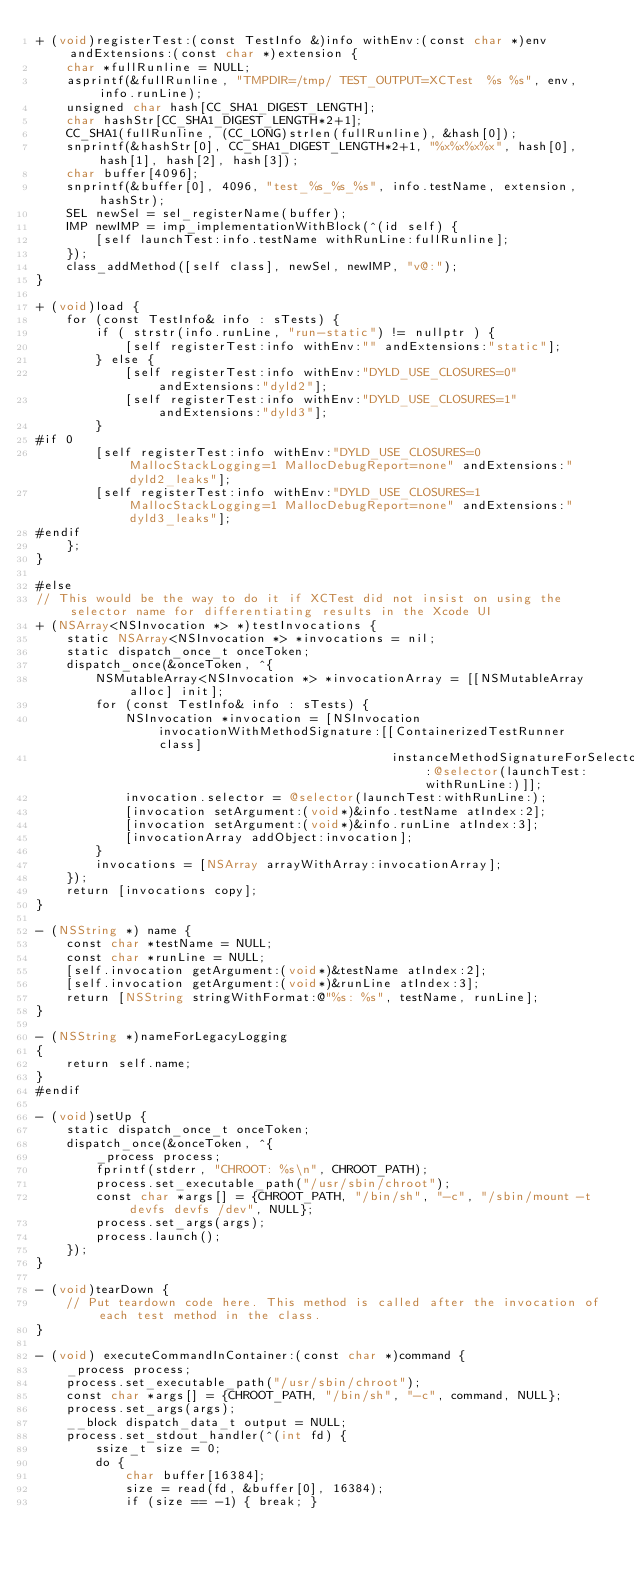<code> <loc_0><loc_0><loc_500><loc_500><_ObjectiveC_>+ (void)registerTest:(const TestInfo &)info withEnv:(const char *)env andExtensions:(const char *)extension {
    char *fullRunline = NULL;
    asprintf(&fullRunline, "TMPDIR=/tmp/ TEST_OUTPUT=XCTest  %s %s", env, info.runLine);
    unsigned char hash[CC_SHA1_DIGEST_LENGTH];
    char hashStr[CC_SHA1_DIGEST_LENGTH*2+1];
    CC_SHA1(fullRunline, (CC_LONG)strlen(fullRunline), &hash[0]);
    snprintf(&hashStr[0], CC_SHA1_DIGEST_LENGTH*2+1, "%x%x%x%x", hash[0], hash[1], hash[2], hash[3]);
    char buffer[4096];
    snprintf(&buffer[0], 4096, "test_%s_%s_%s", info.testName, extension, hashStr);
    SEL newSel = sel_registerName(buffer);
    IMP newIMP = imp_implementationWithBlock(^(id self) {
        [self launchTest:info.testName withRunLine:fullRunline];
    });
    class_addMethod([self class], newSel, newIMP, "v@:");
}

+ (void)load {
    for (const TestInfo& info : sTests) {
        if ( strstr(info.runLine, "run-static") != nullptr ) {
            [self registerTest:info withEnv:"" andExtensions:"static"];
        } else {
            [self registerTest:info withEnv:"DYLD_USE_CLOSURES=0" andExtensions:"dyld2"];
            [self registerTest:info withEnv:"DYLD_USE_CLOSURES=1" andExtensions:"dyld3"];
        }
#if 0
        [self registerTest:info withEnv:"DYLD_USE_CLOSURES=0 MallocStackLogging=1 MallocDebugReport=none" andExtensions:"dyld2_leaks"];
        [self registerTest:info withEnv:"DYLD_USE_CLOSURES=1 MallocStackLogging=1 MallocDebugReport=none" andExtensions:"dyld3_leaks"];
#endif
    };
}

#else
// This would be the way to do it if XCTest did not insist on using the selector name for differentiating results in the Xcode UI
+ (NSArray<NSInvocation *> *)testInvocations {
    static NSArray<NSInvocation *> *invocations = nil;
    static dispatch_once_t onceToken;
    dispatch_once(&onceToken, ^{
        NSMutableArray<NSInvocation *> *invocationArray = [[NSMutableArray alloc] init];
        for (const TestInfo& info : sTests) {
            NSInvocation *invocation = [NSInvocation invocationWithMethodSignature:[[ContainerizedTestRunner class]
                                                instanceMethodSignatureForSelector:@selector(launchTest:withRunLine:)]];
            invocation.selector = @selector(launchTest:withRunLine:);
            [invocation setArgument:(void*)&info.testName atIndex:2];
            [invocation setArgument:(void*)&info.runLine atIndex:3];
            [invocationArray addObject:invocation];
        }
        invocations = [NSArray arrayWithArray:invocationArray];
    });
    return [invocations copy];
}

- (NSString *) name {
    const char *testName = NULL;
    const char *runLine = NULL;
    [self.invocation getArgument:(void*)&testName atIndex:2];
    [self.invocation getArgument:(void*)&runLine atIndex:3];
    return [NSString stringWithFormat:@"%s: %s", testName, runLine];
}

- (NSString *)nameForLegacyLogging
{
    return self.name;
}
#endif

- (void)setUp {
    static dispatch_once_t onceToken;
    dispatch_once(&onceToken, ^{
        _process process;
        fprintf(stderr, "CHROOT: %s\n", CHROOT_PATH);
        process.set_executable_path("/usr/sbin/chroot");
        const char *args[] = {CHROOT_PATH, "/bin/sh", "-c", "/sbin/mount -t devfs devfs /dev", NULL};
        process.set_args(args);
        process.launch();
    });
}

- (void)tearDown {
    // Put teardown code here. This method is called after the invocation of each test method in the class.
}

- (void) executeCommandInContainer:(const char *)command {
    _process process;
    process.set_executable_path("/usr/sbin/chroot");
    const char *args[] = {CHROOT_PATH, "/bin/sh", "-c", command, NULL};
    process.set_args(args);
    __block dispatch_data_t output = NULL;
    process.set_stdout_handler(^(int fd) {
        ssize_t size = 0;
        do {
            char buffer[16384];
            size = read(fd, &buffer[0], 16384);
            if (size == -1) { break; }</code> 